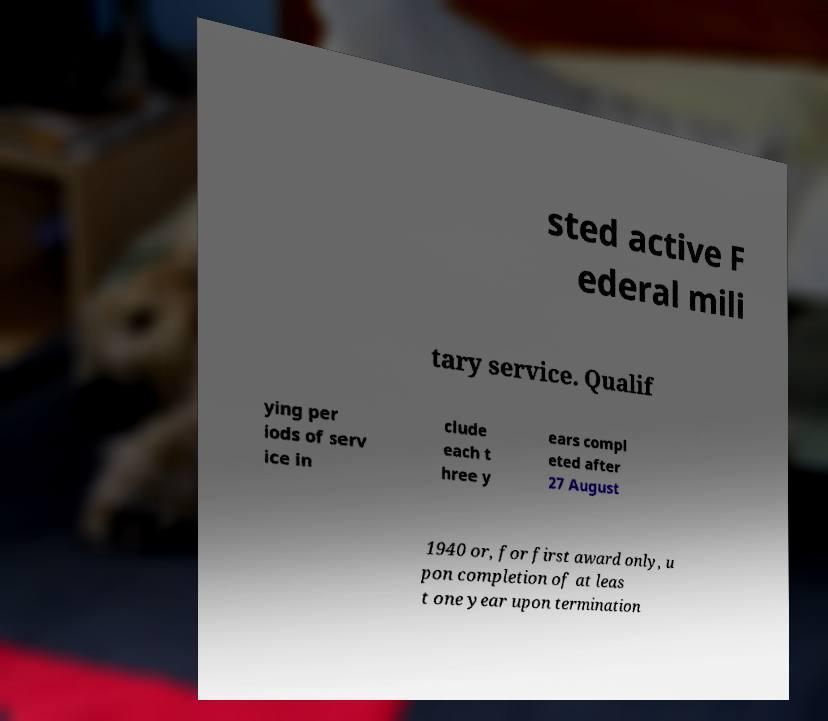What messages or text are displayed in this image? I need them in a readable, typed format. sted active F ederal mili tary service. Qualif ying per iods of serv ice in clude each t hree y ears compl eted after 27 August 1940 or, for first award only, u pon completion of at leas t one year upon termination 